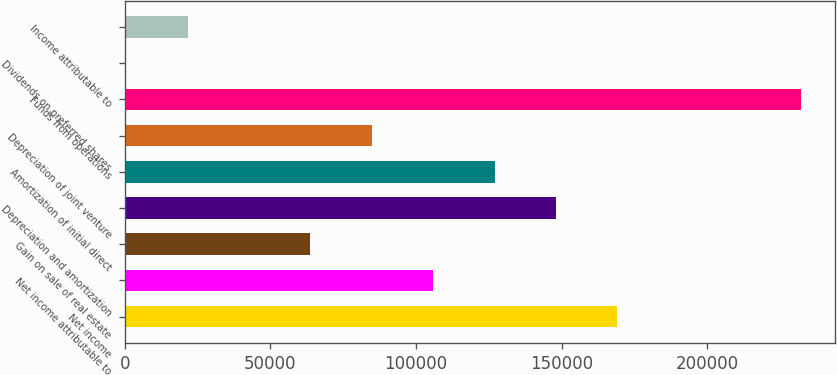<chart> <loc_0><loc_0><loc_500><loc_500><bar_chart><fcel>Net income<fcel>Net income attributable to<fcel>Gain on sale of real estate<fcel>Depreciation and amortization<fcel>Amortization of initial direct<fcel>Depreciation of joint venture<fcel>Funds from operations<fcel>Dividends on preferred shares<fcel>Income attributable to<nl><fcel>169163<fcel>105930<fcel>63774.4<fcel>148086<fcel>127008<fcel>84852.2<fcel>232143<fcel>541<fcel>21618.8<nl></chart> 